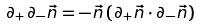<formula> <loc_0><loc_0><loc_500><loc_500>\partial _ { + } \partial _ { - } { \vec { n } } = - { \vec { n } } \, ( \partial _ { + } { \vec { n } } \cdot \partial _ { - } { \vec { n } } )</formula> 